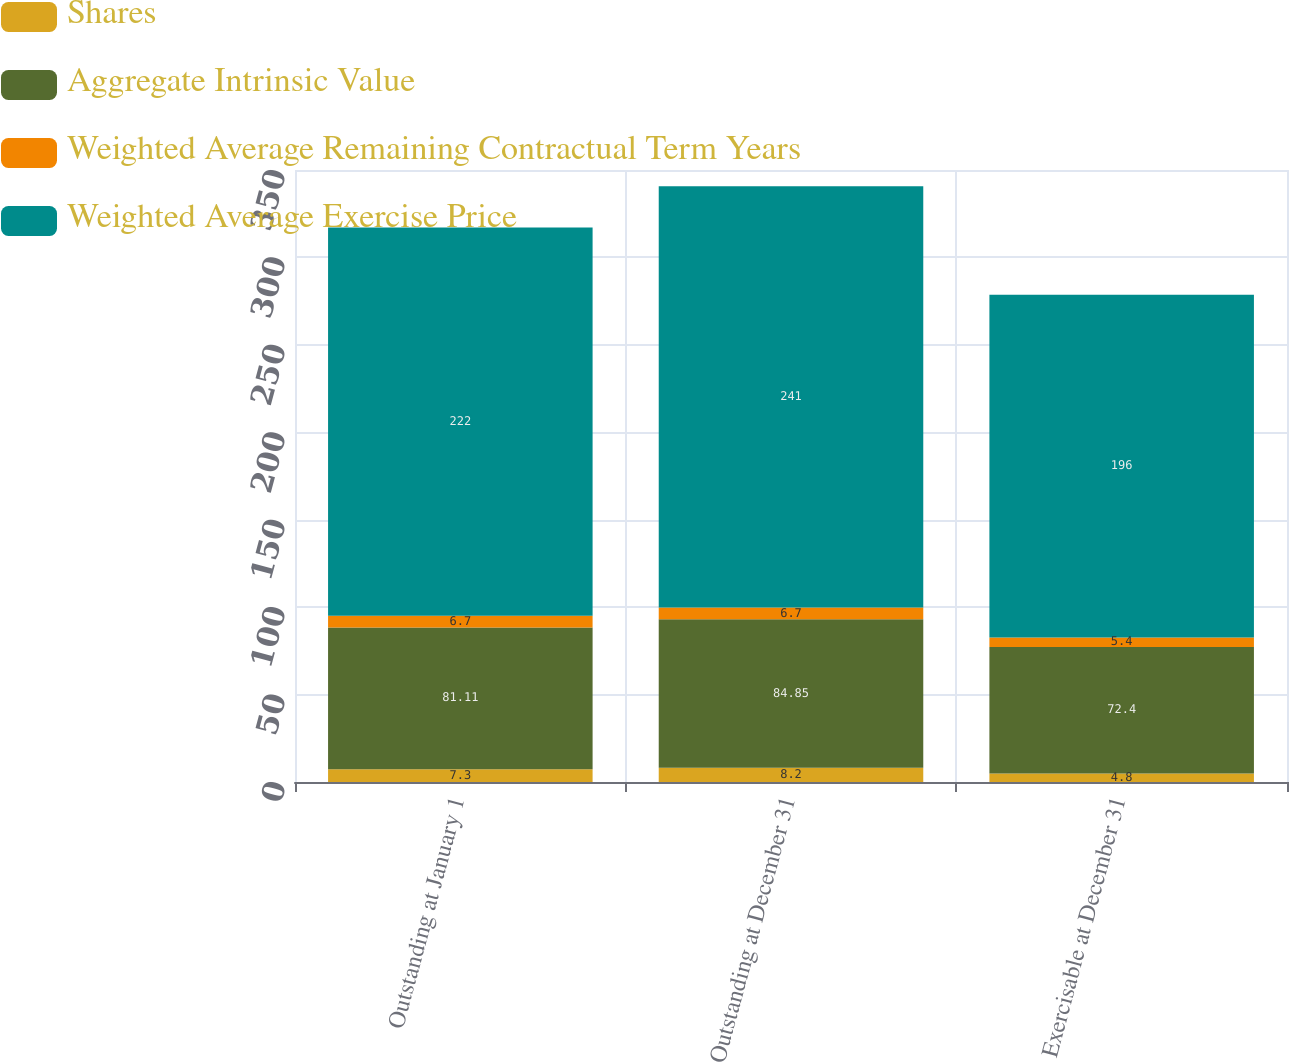<chart> <loc_0><loc_0><loc_500><loc_500><stacked_bar_chart><ecel><fcel>Outstanding at January 1<fcel>Outstanding at December 31<fcel>Exercisable at December 31<nl><fcel>Shares<fcel>7.3<fcel>8.2<fcel>4.8<nl><fcel>Aggregate Intrinsic Value<fcel>81.11<fcel>84.85<fcel>72.4<nl><fcel>Weighted Average Remaining Contractual Term Years<fcel>6.7<fcel>6.7<fcel>5.4<nl><fcel>Weighted Average Exercise Price<fcel>222<fcel>241<fcel>196<nl></chart> 